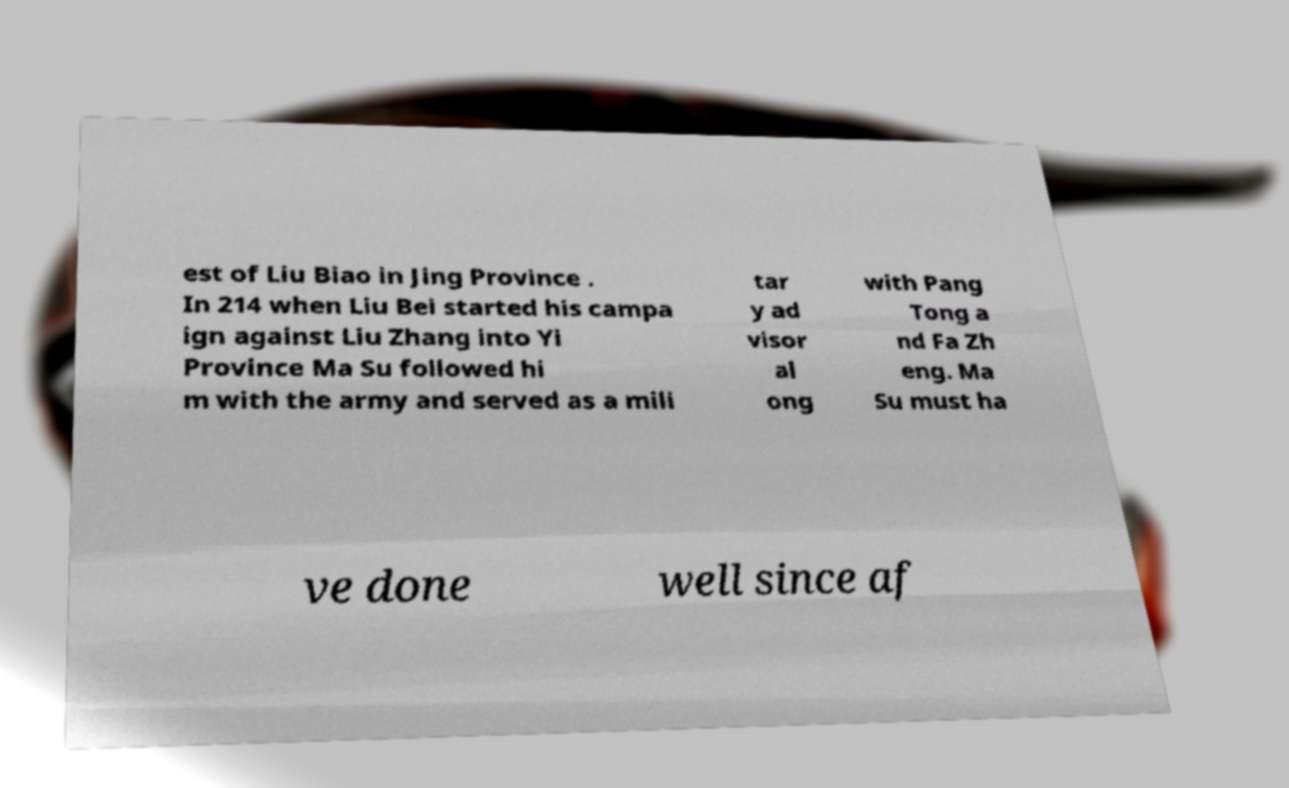What messages or text are displayed in this image? I need them in a readable, typed format. est of Liu Biao in Jing Province . In 214 when Liu Bei started his campa ign against Liu Zhang into Yi Province Ma Su followed hi m with the army and served as a mili tar y ad visor al ong with Pang Tong a nd Fa Zh eng. Ma Su must ha ve done well since af 